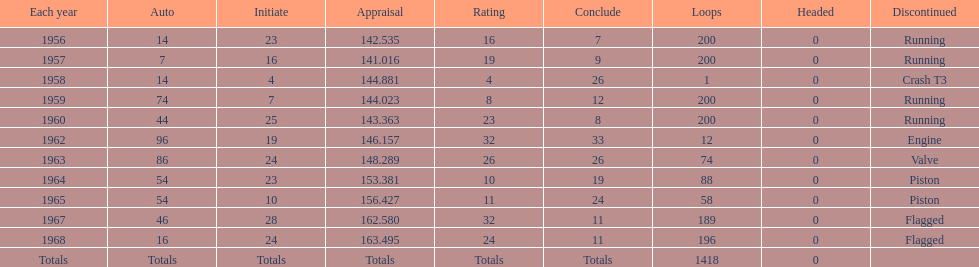Did bob veith drive more indy 500 laps in the 1950s or 1960s? 1960s. 